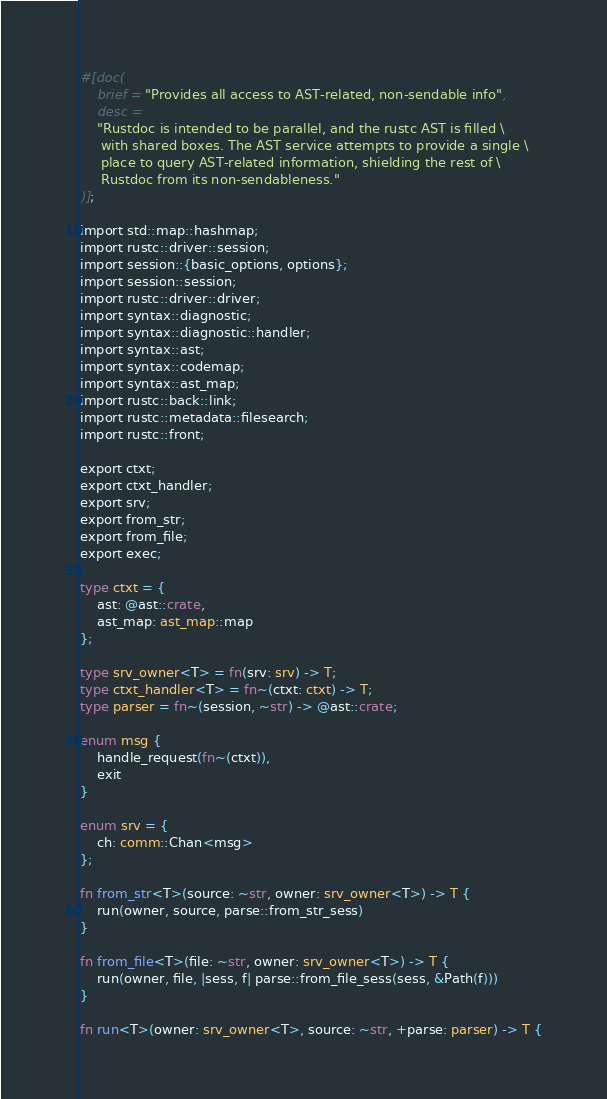Convert code to text. <code><loc_0><loc_0><loc_500><loc_500><_Rust_>#[doc(
    brief = "Provides all access to AST-related, non-sendable info",
    desc =
    "Rustdoc is intended to be parallel, and the rustc AST is filled \
     with shared boxes. The AST service attempts to provide a single \
     place to query AST-related information, shielding the rest of \
     Rustdoc from its non-sendableness."
)];

import std::map::hashmap;
import rustc::driver::session;
import session::{basic_options, options};
import session::session;
import rustc::driver::driver;
import syntax::diagnostic;
import syntax::diagnostic::handler;
import syntax::ast;
import syntax::codemap;
import syntax::ast_map;
import rustc::back::link;
import rustc::metadata::filesearch;
import rustc::front;

export ctxt;
export ctxt_handler;
export srv;
export from_str;
export from_file;
export exec;

type ctxt = {
    ast: @ast::crate,
    ast_map: ast_map::map
};

type srv_owner<T> = fn(srv: srv) -> T;
type ctxt_handler<T> = fn~(ctxt: ctxt) -> T;
type parser = fn~(session, ~str) -> @ast::crate;

enum msg {
    handle_request(fn~(ctxt)),
    exit
}

enum srv = {
    ch: comm::Chan<msg>
};

fn from_str<T>(source: ~str, owner: srv_owner<T>) -> T {
    run(owner, source, parse::from_str_sess)
}

fn from_file<T>(file: ~str, owner: srv_owner<T>) -> T {
    run(owner, file, |sess, f| parse::from_file_sess(sess, &Path(f)))
}

fn run<T>(owner: srv_owner<T>, source: ~str, +parse: parser) -> T {
</code> 